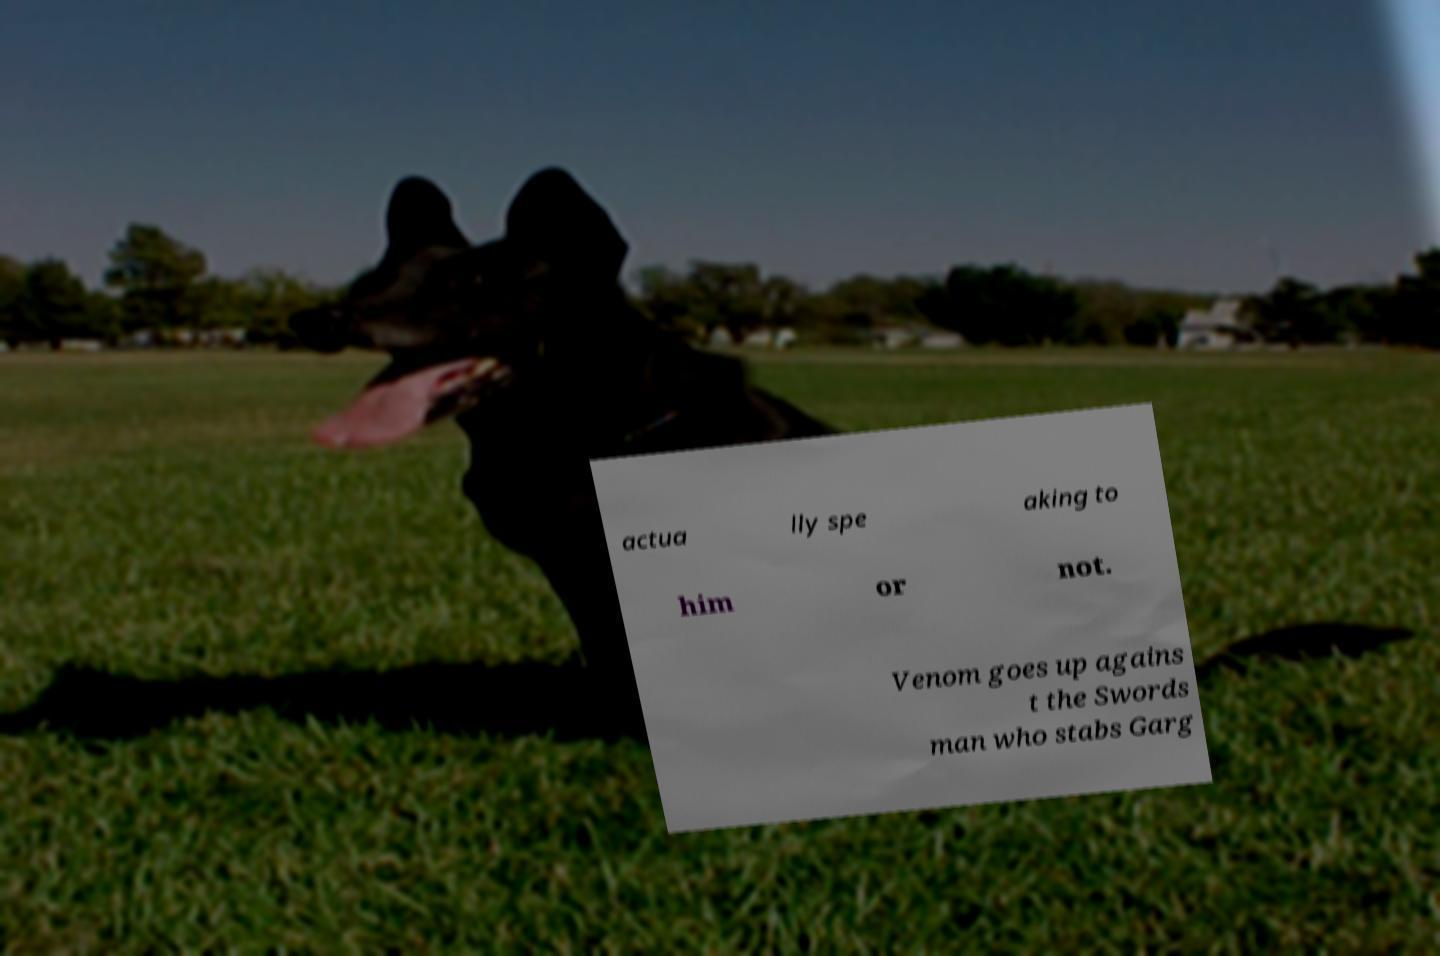Could you assist in decoding the text presented in this image and type it out clearly? actua lly spe aking to him or not. Venom goes up agains t the Swords man who stabs Garg 